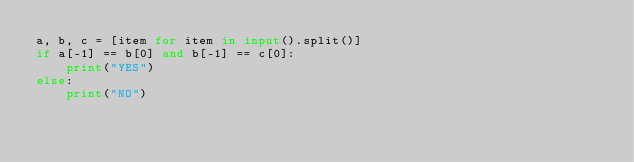Convert code to text. <code><loc_0><loc_0><loc_500><loc_500><_Python_>a, b, c = [item for item in input().split()]
if a[-1] == b[0] and b[-1] == c[0]:
    print("YES")
else:
    print("NO")</code> 